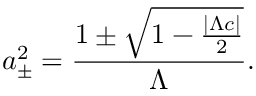Convert formula to latex. <formula><loc_0><loc_0><loc_500><loc_500>a _ { \pm } ^ { 2 } = \frac { 1 \pm \sqrt { 1 - \frac { | \Lambda c | } { 2 } } } { \Lambda } .</formula> 